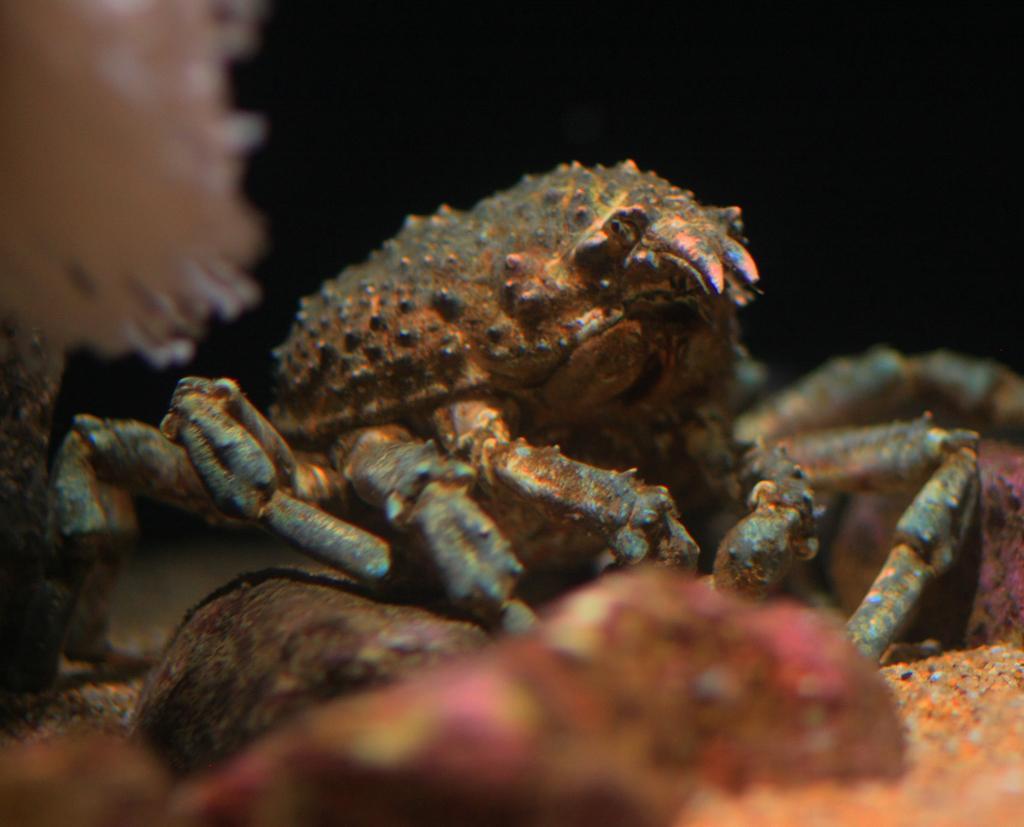Can you describe this image briefly? It looks like the picture is taken in the water. We can see a crab and coral. Behind the crab there is the dark background. In front of the crab those are looking like stones. 